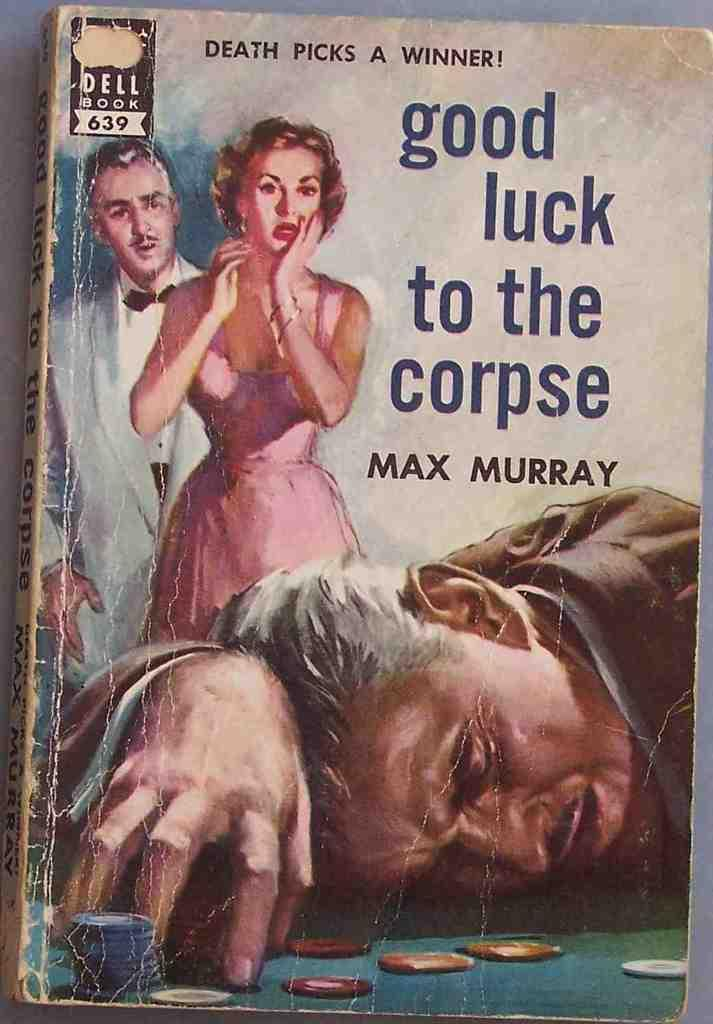<image>
Provide a brief description of the given image. A book titled Good Luck to the Corpse by Max Murray with a label in the top left corner that says Dell Book 639. 